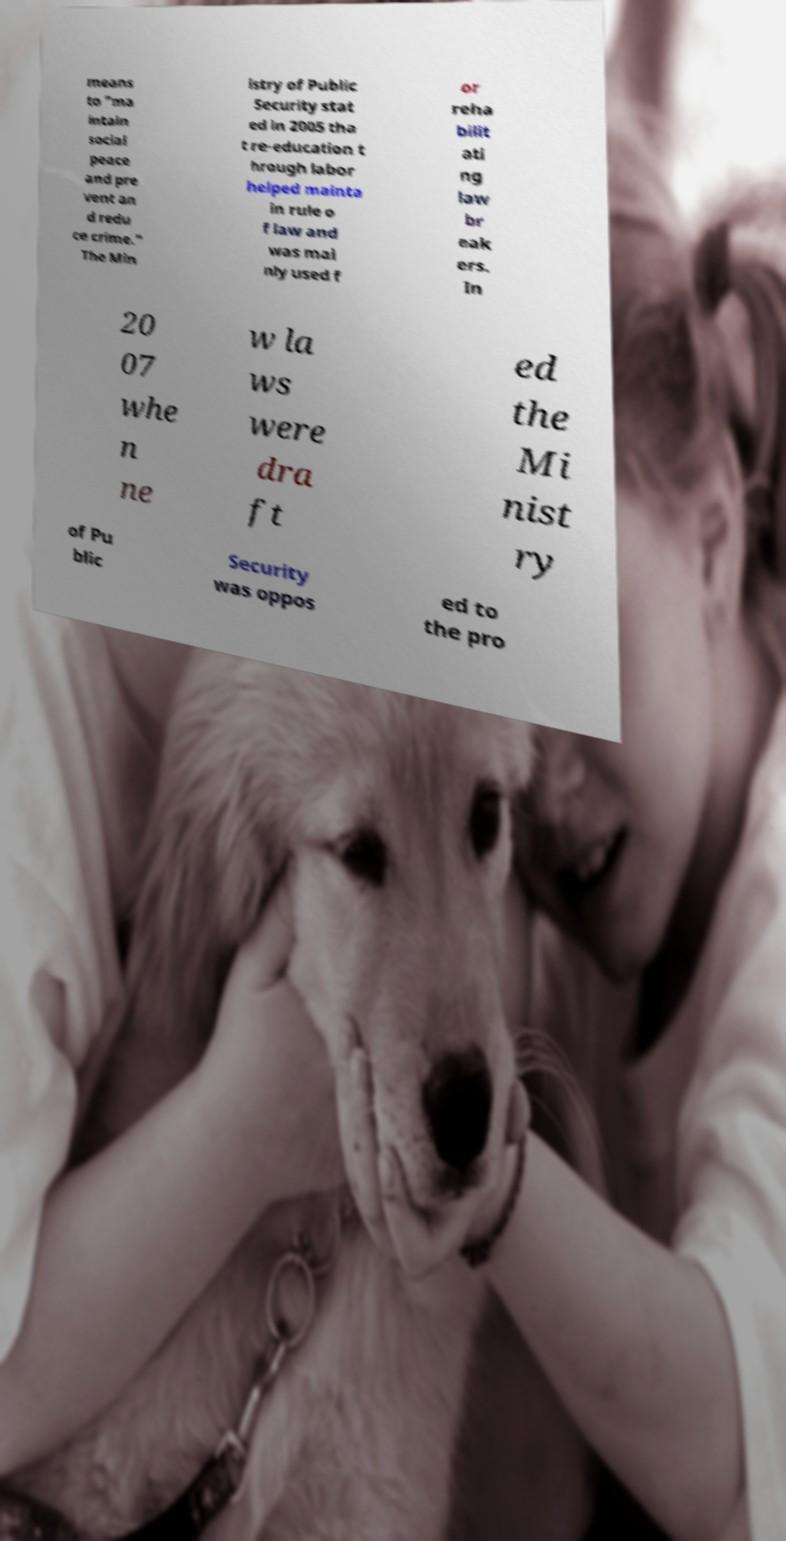Please read and relay the text visible in this image. What does it say? means to "ma intain social peace and pre vent an d redu ce crime." The Min istry of Public Security stat ed in 2005 tha t re-education t hrough labor helped mainta in rule o f law and was mai nly used f or reha bilit ati ng law br eak ers. In 20 07 whe n ne w la ws were dra ft ed the Mi nist ry of Pu blic Security was oppos ed to the pro 